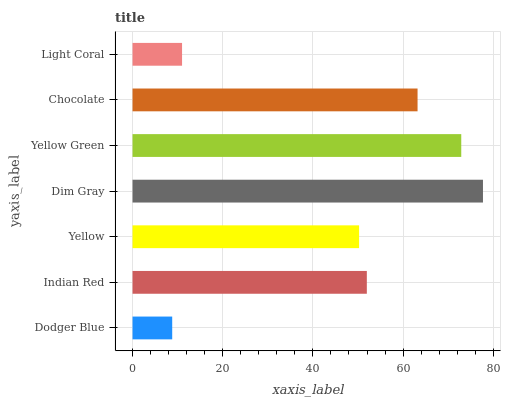Is Dodger Blue the minimum?
Answer yes or no. Yes. Is Dim Gray the maximum?
Answer yes or no. Yes. Is Indian Red the minimum?
Answer yes or no. No. Is Indian Red the maximum?
Answer yes or no. No. Is Indian Red greater than Dodger Blue?
Answer yes or no. Yes. Is Dodger Blue less than Indian Red?
Answer yes or no. Yes. Is Dodger Blue greater than Indian Red?
Answer yes or no. No. Is Indian Red less than Dodger Blue?
Answer yes or no. No. Is Indian Red the high median?
Answer yes or no. Yes. Is Indian Red the low median?
Answer yes or no. Yes. Is Dim Gray the high median?
Answer yes or no. No. Is Chocolate the low median?
Answer yes or no. No. 